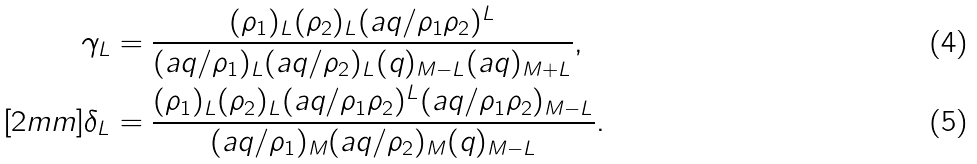<formula> <loc_0><loc_0><loc_500><loc_500>\gamma _ { L } & = \frac { ( \rho _ { 1 } ) _ { L } ( \rho _ { 2 } ) _ { L } ( a q / \rho _ { 1 } \rho _ { 2 } ) ^ { L } } { ( a q / \rho _ { 1 } ) _ { L } ( a q / \rho _ { 2 } ) _ { L } ( q ) _ { M - L } ( a q ) _ { M + L } } , \\ [ 2 m m ] \delta _ { L } & = \frac { ( \rho _ { 1 } ) _ { L } ( \rho _ { 2 } ) _ { L } ( a q / \rho _ { 1 } \rho _ { 2 } ) ^ { L } ( a q / \rho _ { 1 } \rho _ { 2 } ) _ { M - L } } { ( a q / \rho _ { 1 } ) _ { M } ( a q / \rho _ { 2 } ) _ { M } ( q ) _ { M - L } } .</formula> 